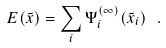<formula> <loc_0><loc_0><loc_500><loc_500>E ( { \tilde { x } } ) = \sum _ { i } \Psi ^ { ( \infty ) } _ { i } ( { \tilde { x } } _ { i } ) \ .</formula> 